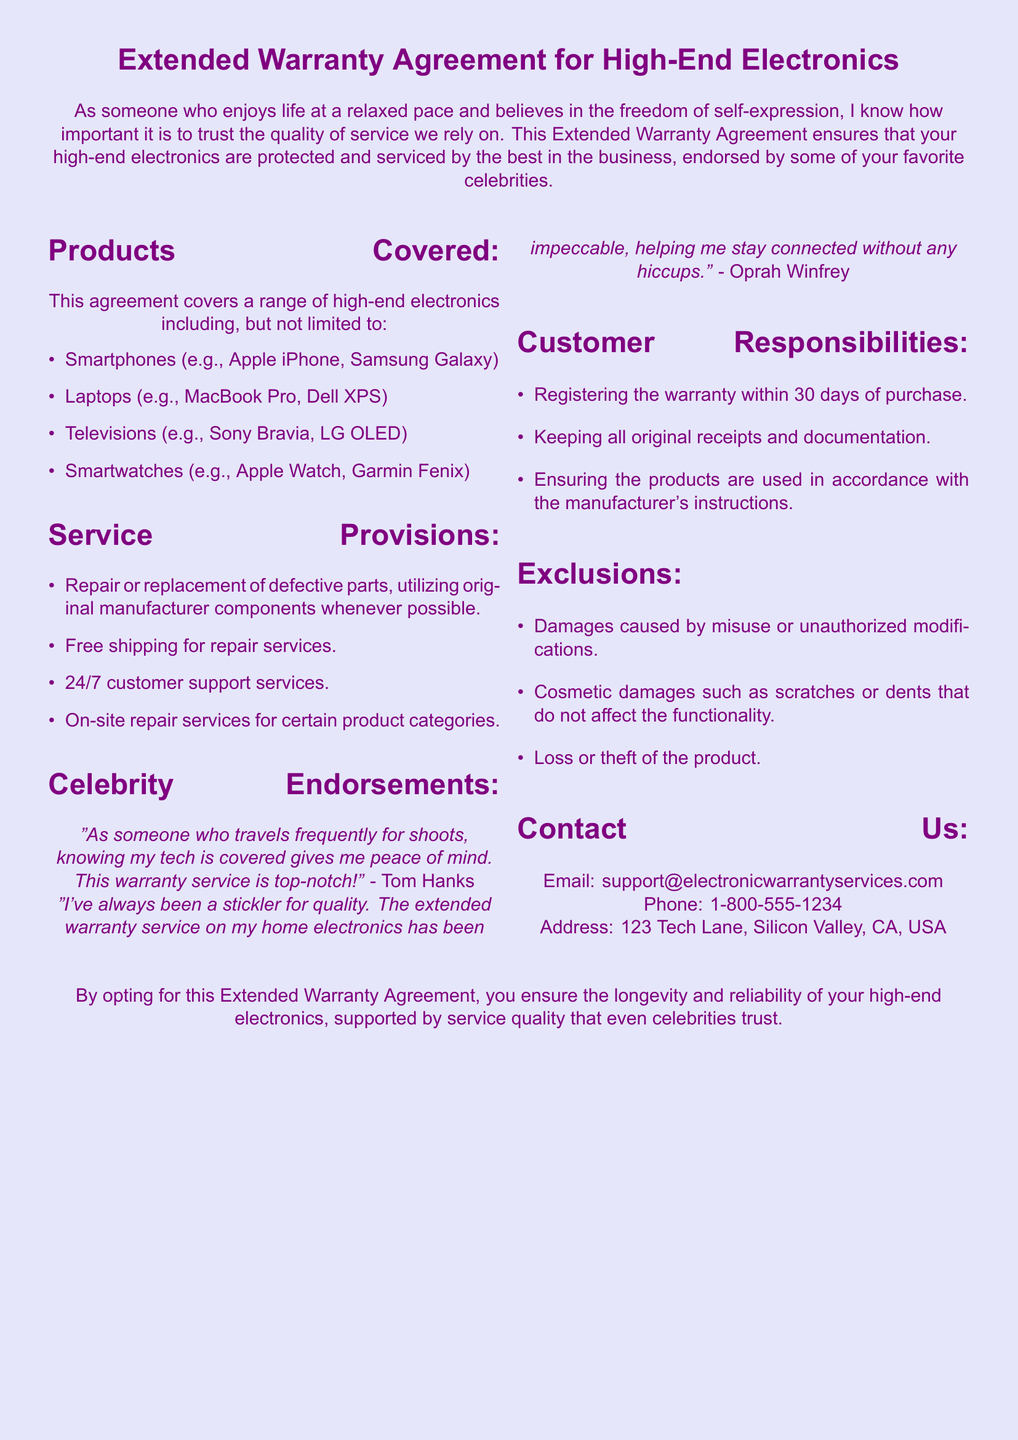What products are covered under this warranty? The products covered include smartphones, laptops, televisions, and smartwatches as listed in the document.
Answer: Smartphones, laptops, televisions, smartwatches Who endorsed the warranty service mentioned in the document? The document mentions celebrities Tom Hanks and Oprah Winfrey endorsing the warranty service.
Answer: Tom Hanks, Oprah Winfrey What should customers do within 30 days of purchase? The document states that customers must register the warranty within 30 days of purchase.
Answer: Register the warranty What type of damages are excluded from the warranty? The document lists specific exclusions, including misuse, cosmetic damages, and loss or theft of the product.
Answer: Misuse, cosmetic damages, loss or theft What kind of customer support is provided? The document states that there is 24/7 customer support services available for warranty holders.
Answer: 24/7 customer support What is required to ensure the longevity of the high-end electronics? The document emphasizes the importance of opting for the Extended Warranty Agreement for the reliability of electronics.
Answer: Extended Warranty Agreement What is the email contact provided in the document? The document specifies the email for customer support as support@electronicwarrantyservices.com.
Answer: support@electronicwarrantyservices.com Name one type of electronic listed under the products covered. The document mentions various electronics, including smartphones.
Answer: Smartphones 